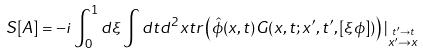<formula> <loc_0><loc_0><loc_500><loc_500>S [ A ] = - i \int ^ { 1 } _ { 0 } d \xi \int d t d ^ { 2 } x t r \left ( \hat { \phi } ( x , t ) G ( x , t ; x ^ { \prime } , t ^ { \prime } , [ \xi \phi ] ) \right ) | _ { \stackrel { t ^ { \prime } \rightarrow t } { x ^ { \prime } \rightarrow x } }</formula> 